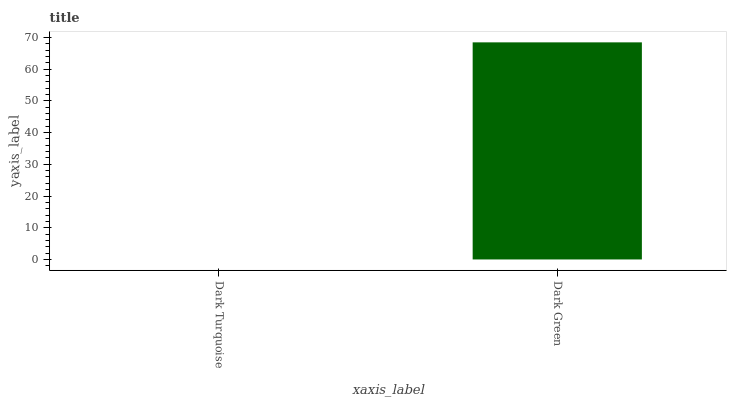Is Dark Green the minimum?
Answer yes or no. No. Is Dark Green greater than Dark Turquoise?
Answer yes or no. Yes. Is Dark Turquoise less than Dark Green?
Answer yes or no. Yes. Is Dark Turquoise greater than Dark Green?
Answer yes or no. No. Is Dark Green less than Dark Turquoise?
Answer yes or no. No. Is Dark Green the high median?
Answer yes or no. Yes. Is Dark Turquoise the low median?
Answer yes or no. Yes. Is Dark Turquoise the high median?
Answer yes or no. No. Is Dark Green the low median?
Answer yes or no. No. 